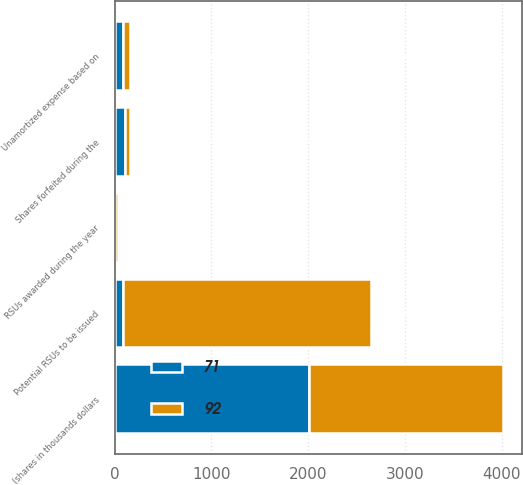<chart> <loc_0><loc_0><loc_500><loc_500><stacked_bar_chart><ecel><fcel>(shares in thousands dollars<fcel>Potential RSUs to be issued<fcel>Shares forfeited during the<fcel>RSUs awarded during the year<fcel>Unamortized expense based on<nl><fcel>71<fcel>2007<fcel>92<fcel>109<fcel>9<fcel>92<nl><fcel>92<fcel>2006<fcel>2560<fcel>49<fcel>30<fcel>71<nl></chart> 